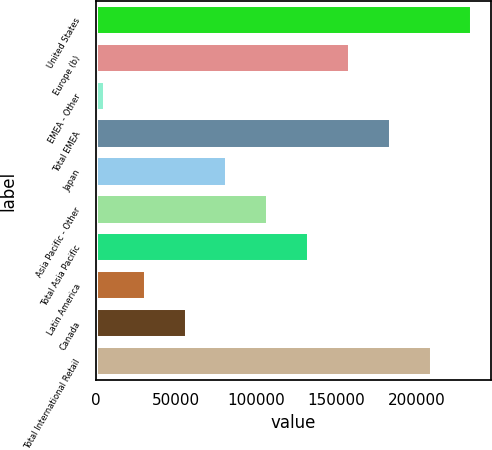Convert chart. <chart><loc_0><loc_0><loc_500><loc_500><bar_chart><fcel>United States<fcel>Europe (b)<fcel>EMEA - Other<fcel>Total EMEA<fcel>Japan<fcel>Asia Pacific - Other<fcel>Total Asia Pacific<fcel>Latin America<fcel>Canada<fcel>Total International Retail<nl><fcel>234850<fcel>158532<fcel>5896<fcel>183971<fcel>82213.9<fcel>107653<fcel>133092<fcel>31335.3<fcel>56774.6<fcel>209410<nl></chart> 